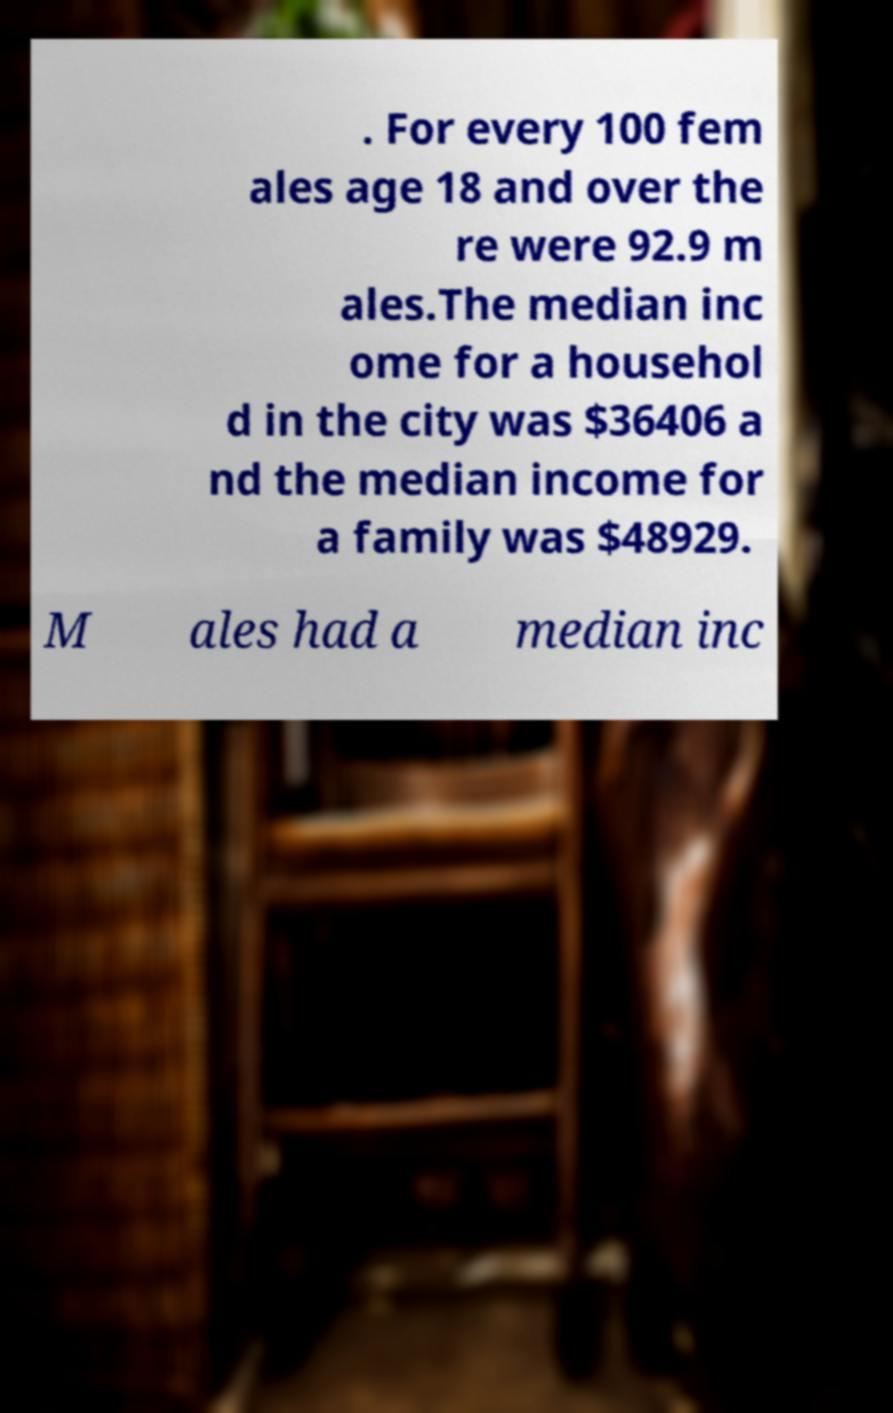Could you extract and type out the text from this image? . For every 100 fem ales age 18 and over the re were 92.9 m ales.The median inc ome for a househol d in the city was $36406 a nd the median income for a family was $48929. M ales had a median inc 